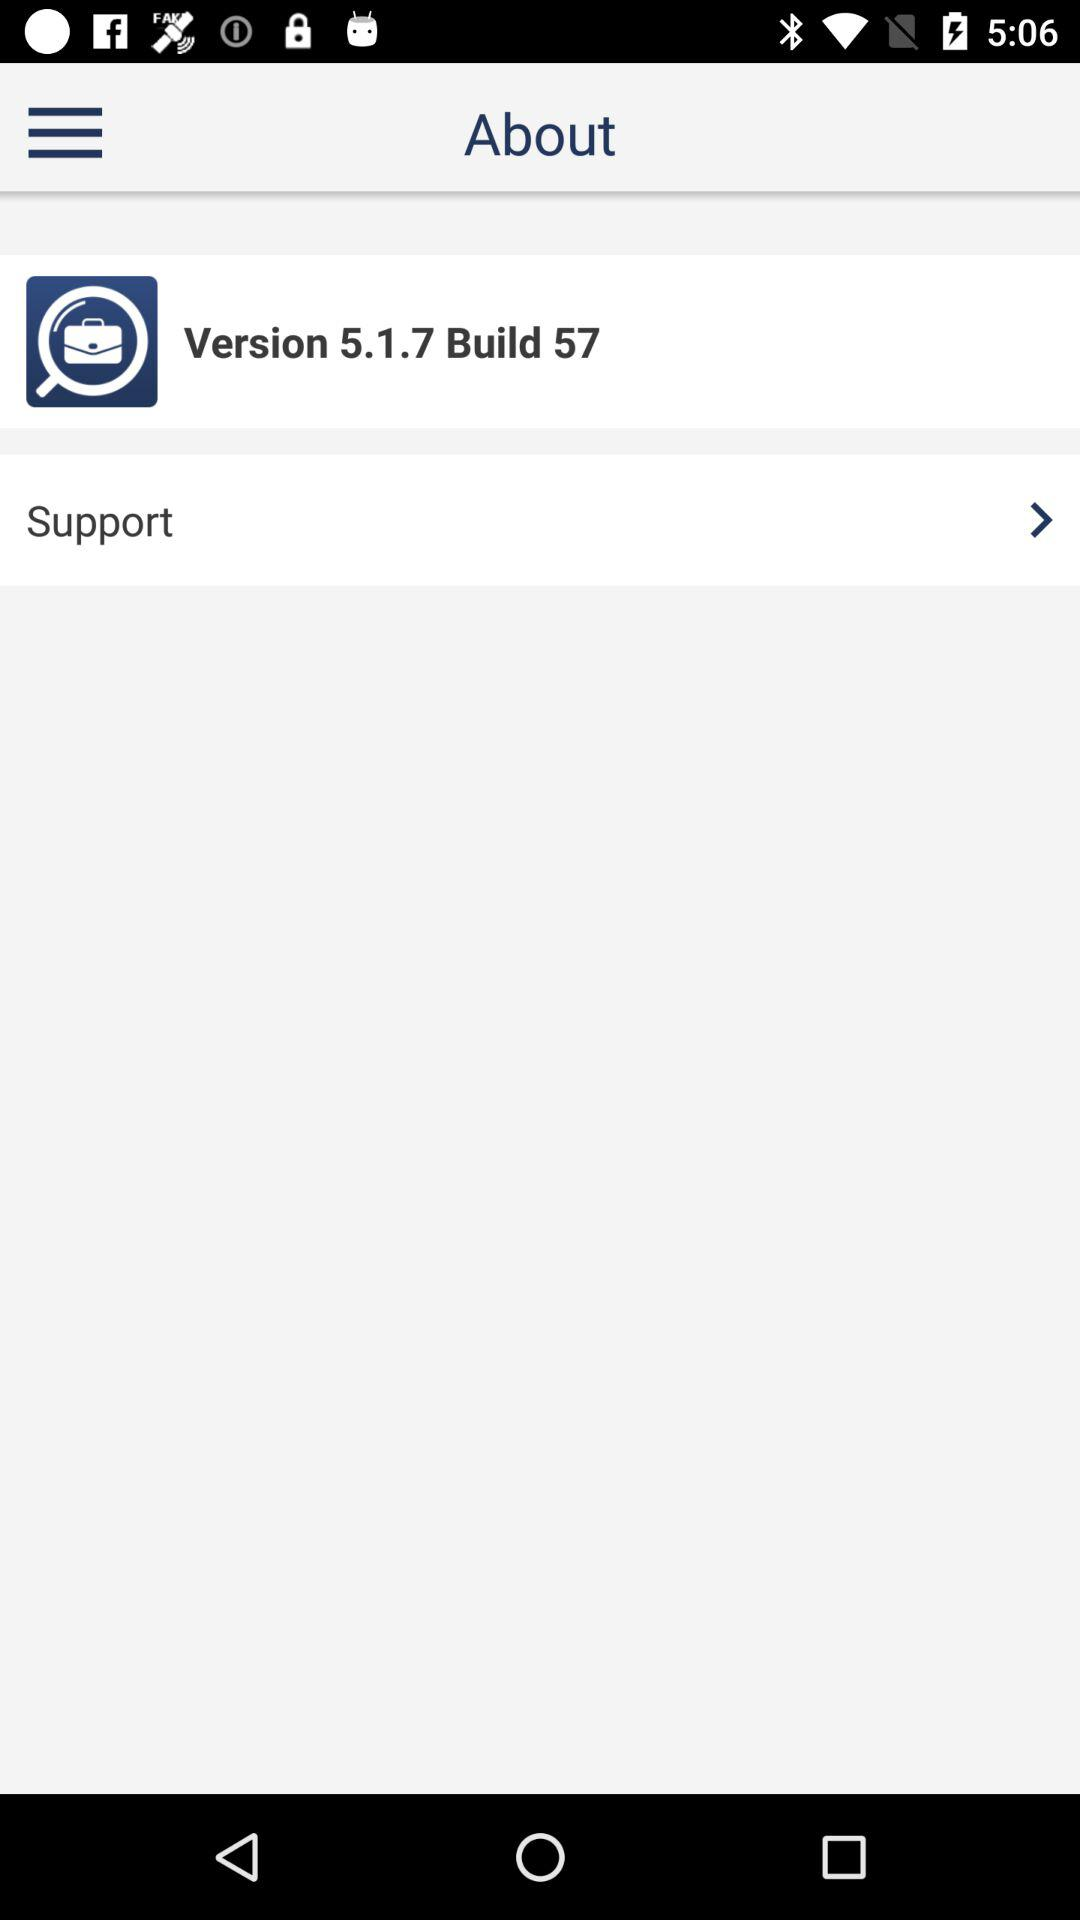What is the displayed version? The displayed version is 5.1.7. 